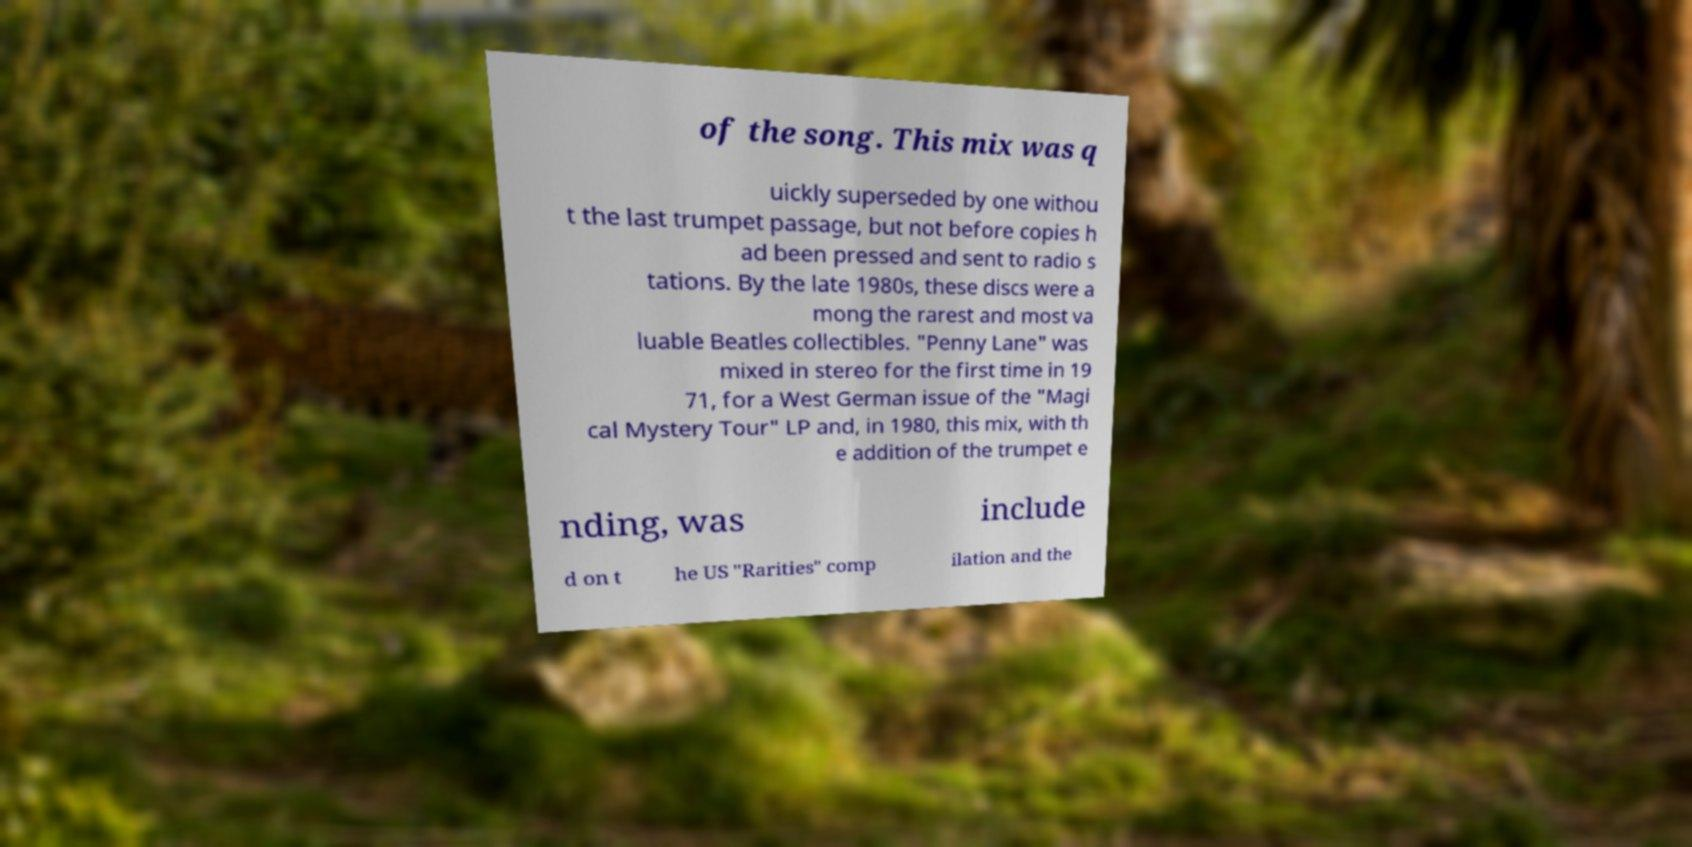There's text embedded in this image that I need extracted. Can you transcribe it verbatim? of the song. This mix was q uickly superseded by one withou t the last trumpet passage, but not before copies h ad been pressed and sent to radio s tations. By the late 1980s, these discs were a mong the rarest and most va luable Beatles collectibles. "Penny Lane" was mixed in stereo for the first time in 19 71, for a West German issue of the "Magi cal Mystery Tour" LP and, in 1980, this mix, with th e addition of the trumpet e nding, was include d on t he US "Rarities" comp ilation and the 